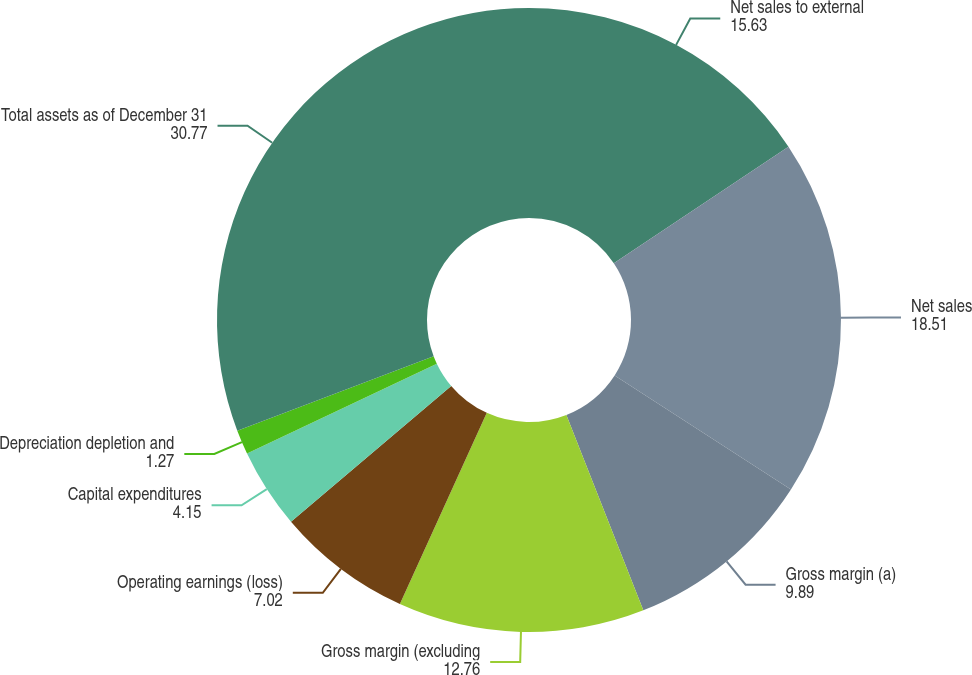Convert chart to OTSL. <chart><loc_0><loc_0><loc_500><loc_500><pie_chart><fcel>Net sales to external<fcel>Net sales<fcel>Gross margin (a)<fcel>Gross margin (excluding<fcel>Operating earnings (loss)<fcel>Capital expenditures<fcel>Depreciation depletion and<fcel>Total assets as of December 31<nl><fcel>15.63%<fcel>18.51%<fcel>9.89%<fcel>12.76%<fcel>7.02%<fcel>4.15%<fcel>1.27%<fcel>30.77%<nl></chart> 